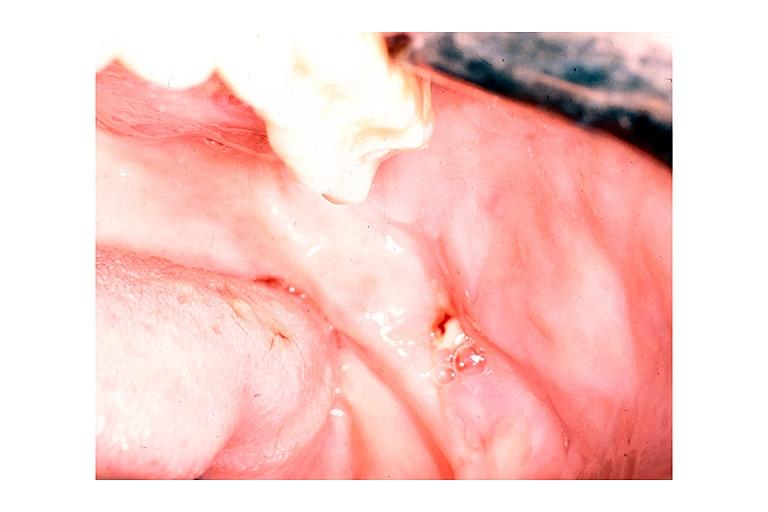where is this?
Answer the question using a single word or phrase. Oral 